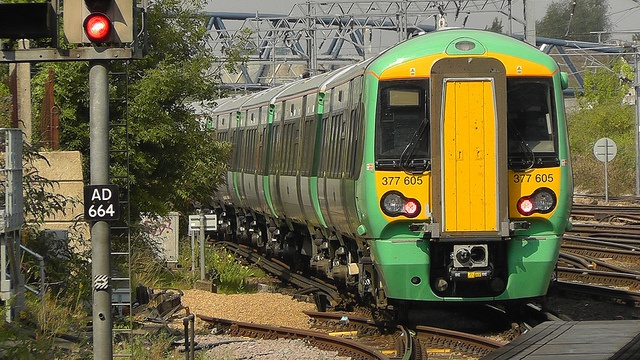Describe the objects in this image and their specific colors. I can see train in olive, black, gray, orange, and darkgreen tones and traffic light in olive, tan, black, and maroon tones in this image. 